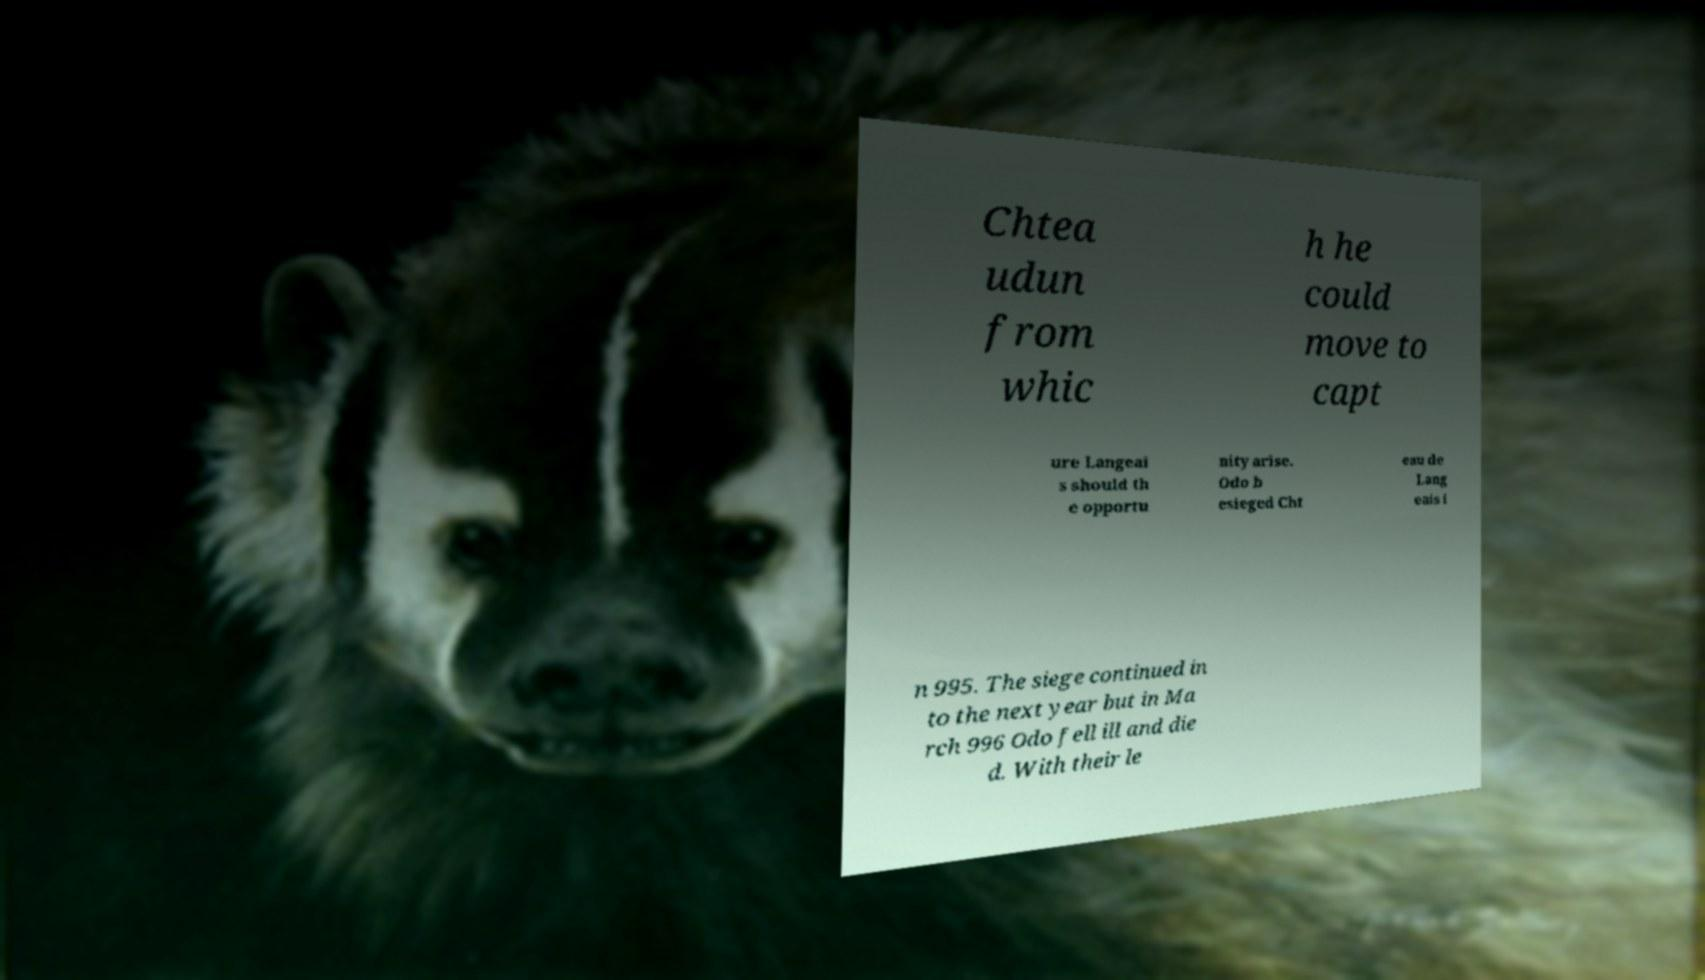I need the written content from this picture converted into text. Can you do that? Chtea udun from whic h he could move to capt ure Langeai s should th e opportu nity arise. Odo b esieged Cht eau de Lang eais i n 995. The siege continued in to the next year but in Ma rch 996 Odo fell ill and die d. With their le 